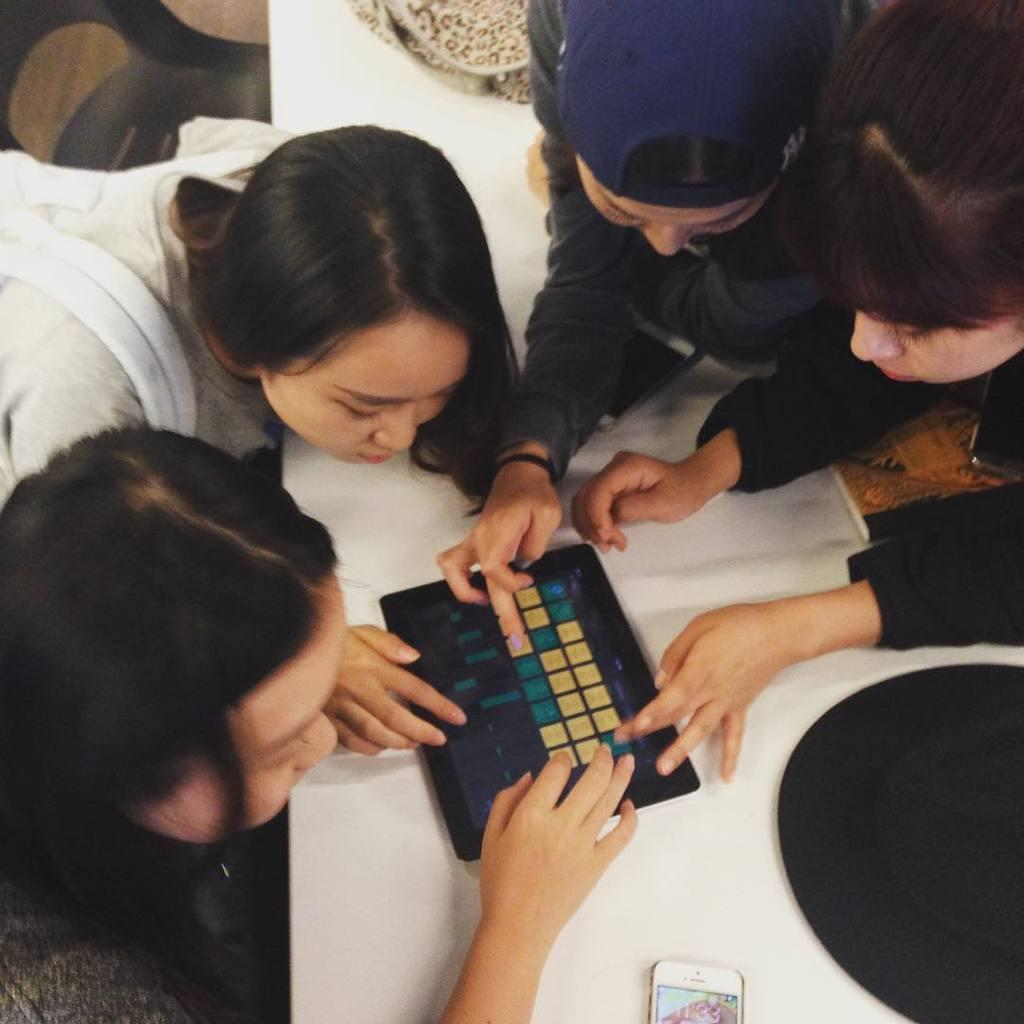How many people are playing in the image? There are four people playing in the image. What are the people playing on? The people are playing on a tablet. Can you see any other electronic devices in the image? Yes, there is a mobile phone visible in the image. What is on the floor in the image? There are objects on the floor in the image. What type of body is being balanced on the tablet in the image? There is no body being balanced on the tablet in the image; the people are playing games on the tablet. Can you see any bananas in the image? There are no bananas present in the image. 